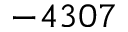Convert formula to latex. <formula><loc_0><loc_0><loc_500><loc_500>- 4 3 0 7</formula> 